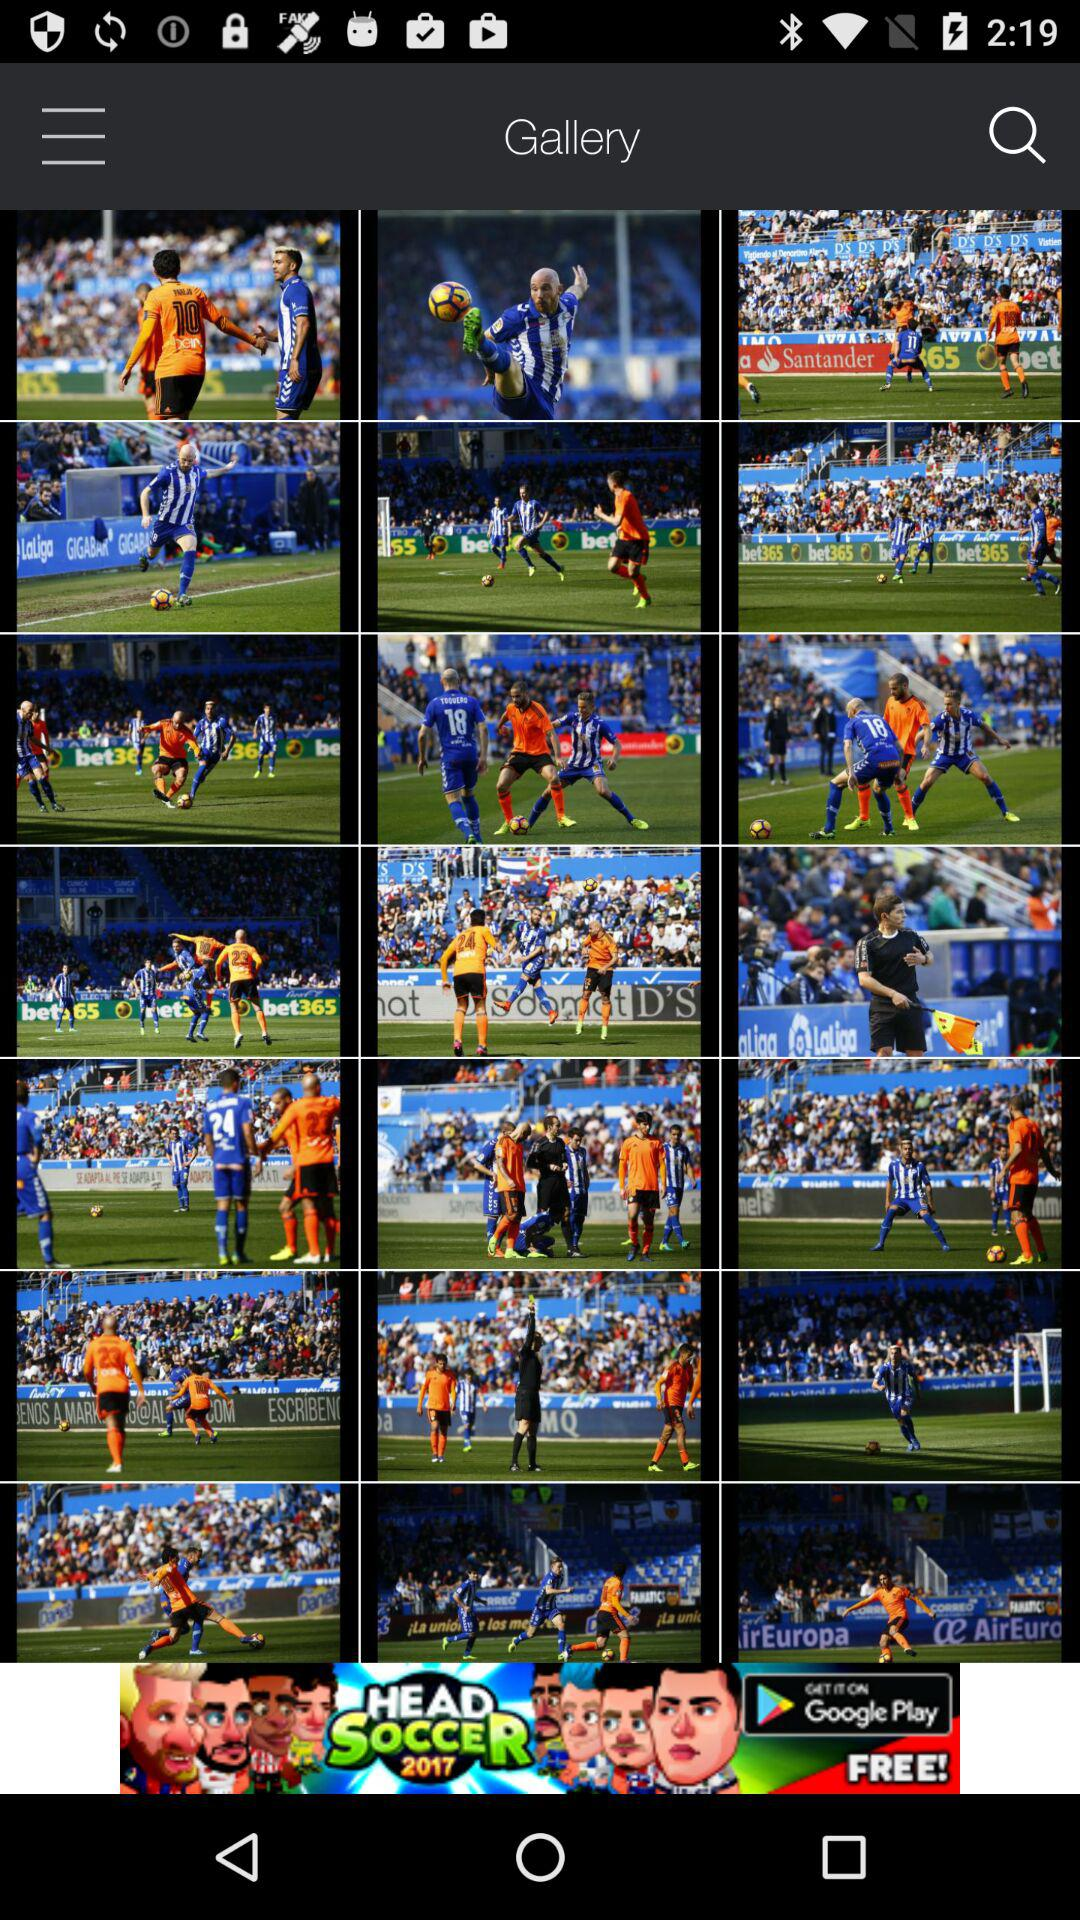What is the app name? The app name is "Gallery". 